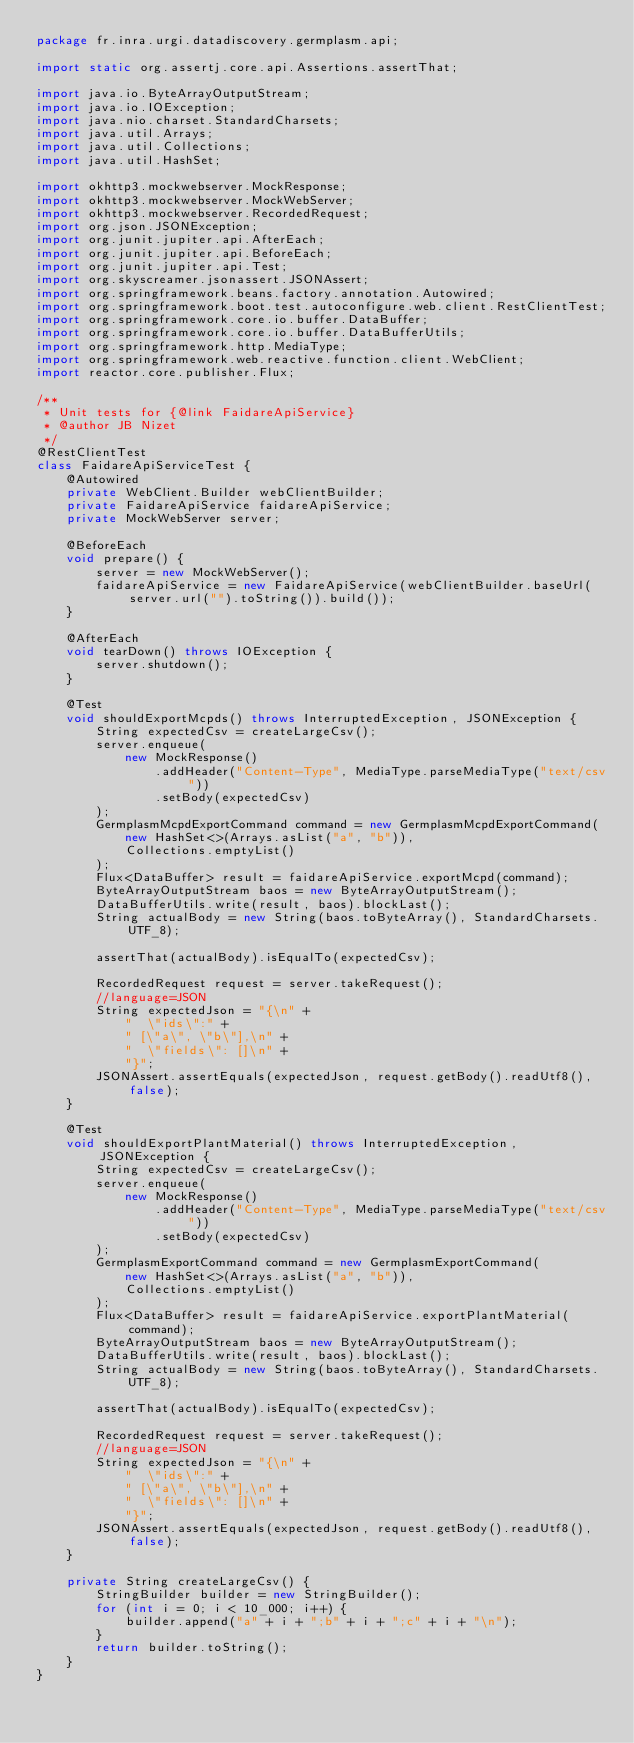<code> <loc_0><loc_0><loc_500><loc_500><_Java_>package fr.inra.urgi.datadiscovery.germplasm.api;

import static org.assertj.core.api.Assertions.assertThat;

import java.io.ByteArrayOutputStream;
import java.io.IOException;
import java.nio.charset.StandardCharsets;
import java.util.Arrays;
import java.util.Collections;
import java.util.HashSet;

import okhttp3.mockwebserver.MockResponse;
import okhttp3.mockwebserver.MockWebServer;
import okhttp3.mockwebserver.RecordedRequest;
import org.json.JSONException;
import org.junit.jupiter.api.AfterEach;
import org.junit.jupiter.api.BeforeEach;
import org.junit.jupiter.api.Test;
import org.skyscreamer.jsonassert.JSONAssert;
import org.springframework.beans.factory.annotation.Autowired;
import org.springframework.boot.test.autoconfigure.web.client.RestClientTest;
import org.springframework.core.io.buffer.DataBuffer;
import org.springframework.core.io.buffer.DataBufferUtils;
import org.springframework.http.MediaType;
import org.springframework.web.reactive.function.client.WebClient;
import reactor.core.publisher.Flux;

/**
 * Unit tests for {@link FaidareApiService}
 * @author JB Nizet
 */
@RestClientTest
class FaidareApiServiceTest {
    @Autowired
    private WebClient.Builder webClientBuilder;
    private FaidareApiService faidareApiService;
    private MockWebServer server;

    @BeforeEach
    void prepare() {
        server = new MockWebServer();
        faidareApiService = new FaidareApiService(webClientBuilder.baseUrl(server.url("").toString()).build());
    }

    @AfterEach
    void tearDown() throws IOException {
        server.shutdown();
    }

    @Test
    void shouldExportMcpds() throws InterruptedException, JSONException {
        String expectedCsv = createLargeCsv();
        server.enqueue(
            new MockResponse()
                .addHeader("Content-Type", MediaType.parseMediaType("text/csv"))
                .setBody(expectedCsv)
        );
        GermplasmMcpdExportCommand command = new GermplasmMcpdExportCommand(
            new HashSet<>(Arrays.asList("a", "b")),
            Collections.emptyList()
        );
        Flux<DataBuffer> result = faidareApiService.exportMcpd(command);
        ByteArrayOutputStream baos = new ByteArrayOutputStream();
        DataBufferUtils.write(result, baos).blockLast();
        String actualBody = new String(baos.toByteArray(), StandardCharsets.UTF_8);

        assertThat(actualBody).isEqualTo(expectedCsv);

        RecordedRequest request = server.takeRequest();
        //language=JSON
        String expectedJson = "{\n" +
            "  \"ids\":" +
            " [\"a\", \"b\"],\n" +
            "  \"fields\": []\n" +
            "}";
        JSONAssert.assertEquals(expectedJson, request.getBody().readUtf8(), false);
    }

    @Test
    void shouldExportPlantMaterial() throws InterruptedException, JSONException {
        String expectedCsv = createLargeCsv();
        server.enqueue(
            new MockResponse()
                .addHeader("Content-Type", MediaType.parseMediaType("text/csv"))
                .setBody(expectedCsv)
        );
        GermplasmExportCommand command = new GermplasmExportCommand(
            new HashSet<>(Arrays.asList("a", "b")),
            Collections.emptyList()
        );
        Flux<DataBuffer> result = faidareApiService.exportPlantMaterial(command);
        ByteArrayOutputStream baos = new ByteArrayOutputStream();
        DataBufferUtils.write(result, baos).blockLast();
        String actualBody = new String(baos.toByteArray(), StandardCharsets.UTF_8);

        assertThat(actualBody).isEqualTo(expectedCsv);

        RecordedRequest request = server.takeRequest();
        //language=JSON
        String expectedJson = "{\n" +
            "  \"ids\":" +
            " [\"a\", \"b\"],\n" +
            "  \"fields\": []\n" +
            "}";
        JSONAssert.assertEquals(expectedJson, request.getBody().readUtf8(), false);
    }

    private String createLargeCsv() {
        StringBuilder builder = new StringBuilder();
        for (int i = 0; i < 10_000; i++) {
            builder.append("a" + i + ";b" + i + ";c" + i + "\n");
        }
        return builder.toString();
    }
}
</code> 